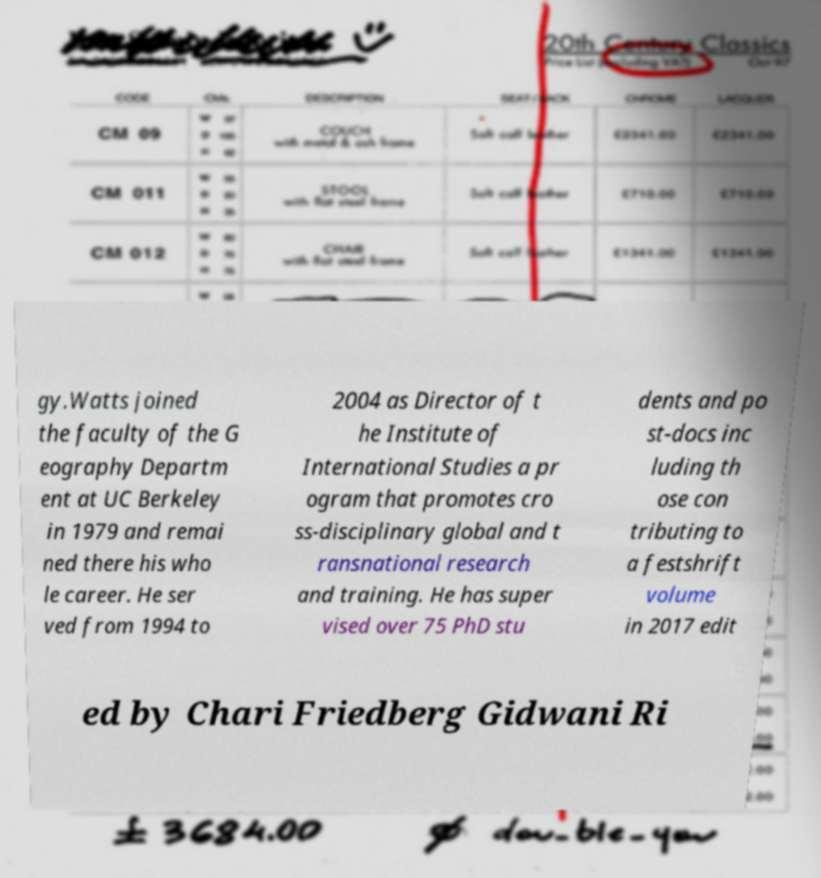Could you extract and type out the text from this image? gy.Watts joined the faculty of the G eography Departm ent at UC Berkeley in 1979 and remai ned there his who le career. He ser ved from 1994 to 2004 as Director of t he Institute of International Studies a pr ogram that promotes cro ss-disciplinary global and t ransnational research and training. He has super vised over 75 PhD stu dents and po st-docs inc luding th ose con tributing to a festshrift volume in 2017 edit ed by Chari Friedberg Gidwani Ri 